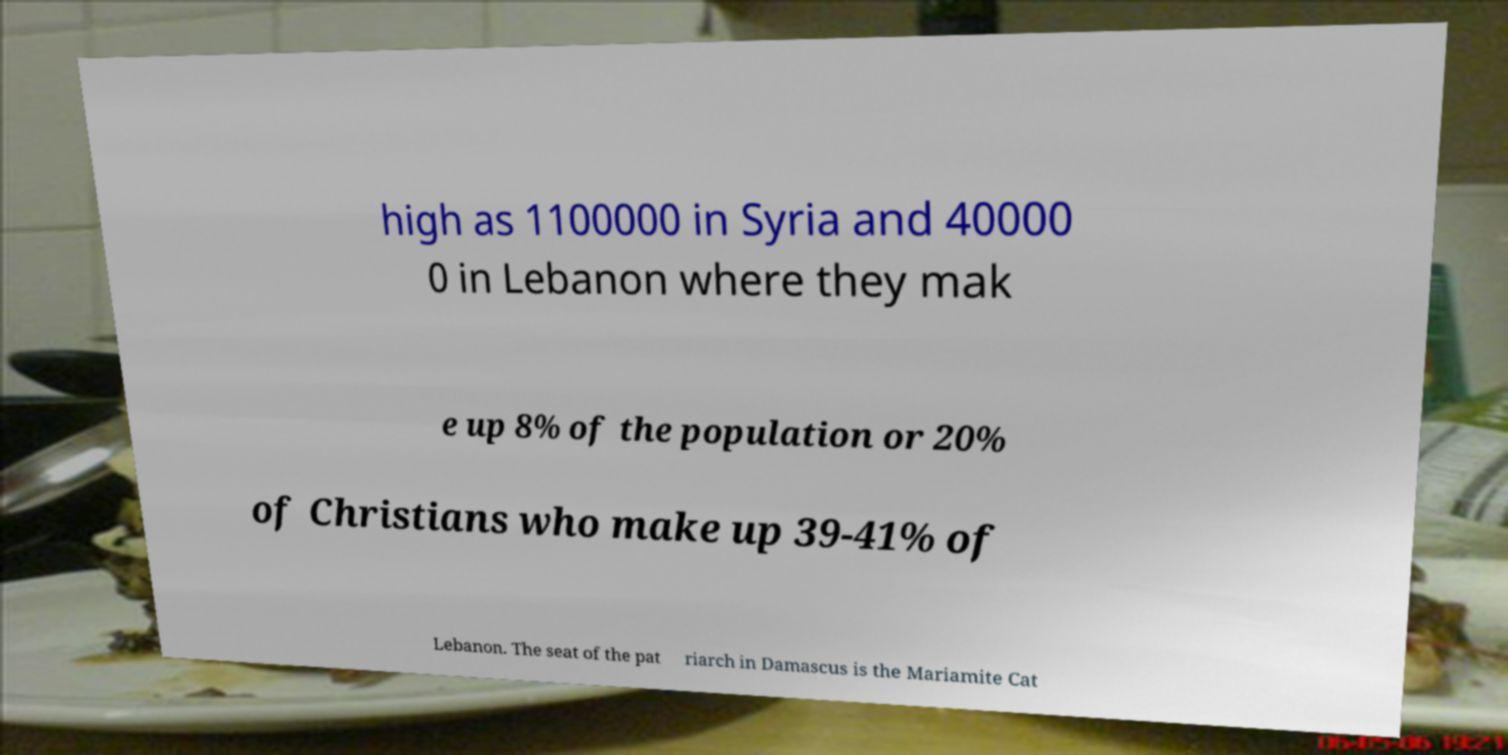There's text embedded in this image that I need extracted. Can you transcribe it verbatim? high as 1100000 in Syria and 40000 0 in Lebanon where they mak e up 8% of the population or 20% of Christians who make up 39-41% of Lebanon. The seat of the pat riarch in Damascus is the Mariamite Cat 